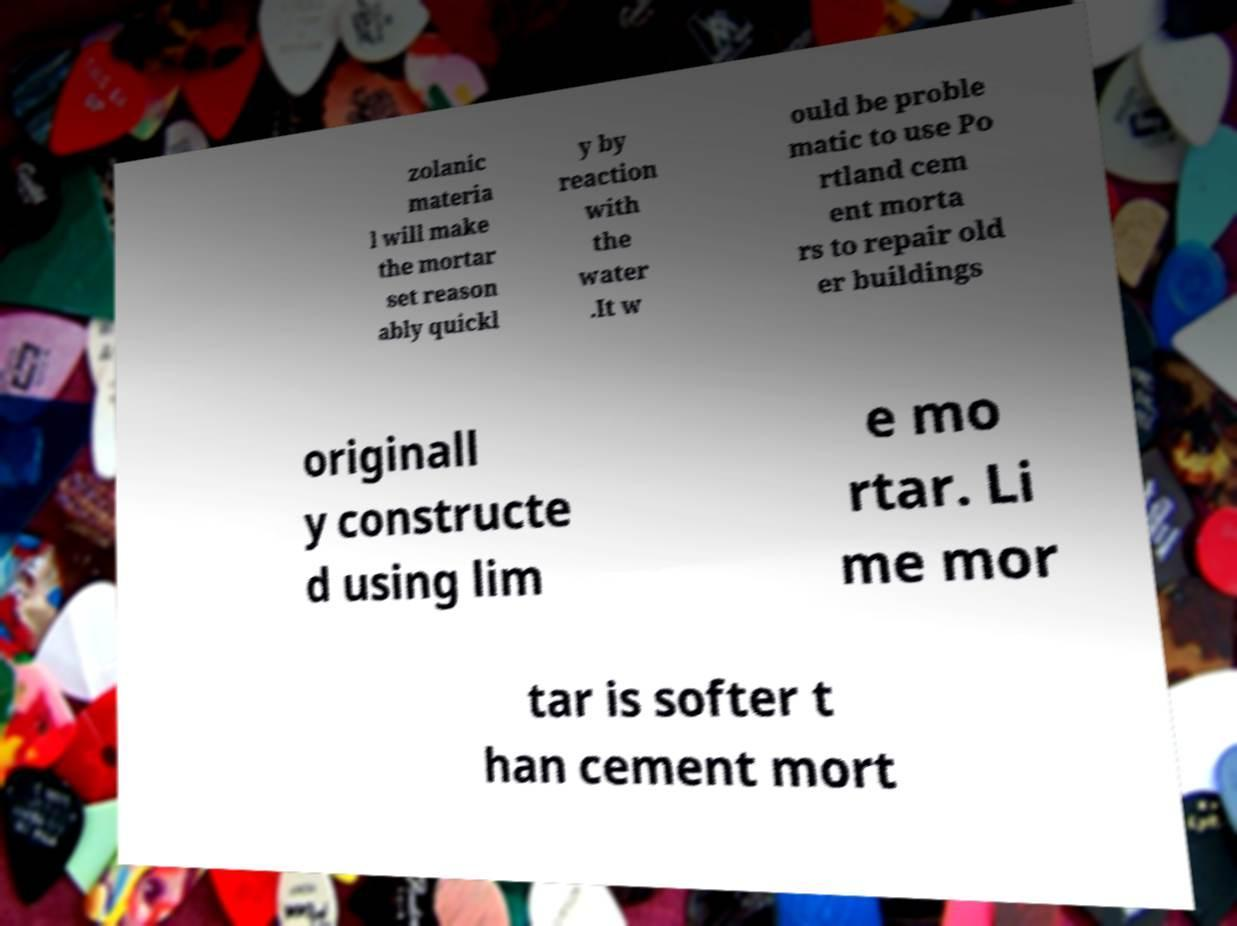Could you extract and type out the text from this image? zolanic materia l will make the mortar set reason ably quickl y by reaction with the water .It w ould be proble matic to use Po rtland cem ent morta rs to repair old er buildings originall y constructe d using lim e mo rtar. Li me mor tar is softer t han cement mort 